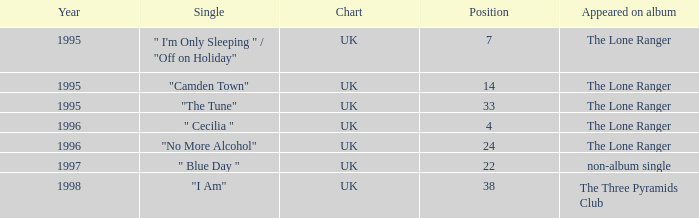After 1996, what is the average position? 30.0. 